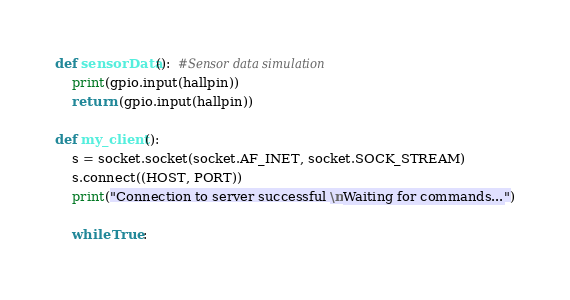<code> <loc_0><loc_0><loc_500><loc_500><_Python_>def sensorData():  #Sensor data simulation
    print(gpio.input(hallpin))
    return (gpio.input(hallpin))

def my_client():
    s = socket.socket(socket.AF_INET, socket.SOCK_STREAM)
    s.connect((HOST, PORT))
    print("Connection to server successful \nWaiting for commands...")

    while True:</code> 